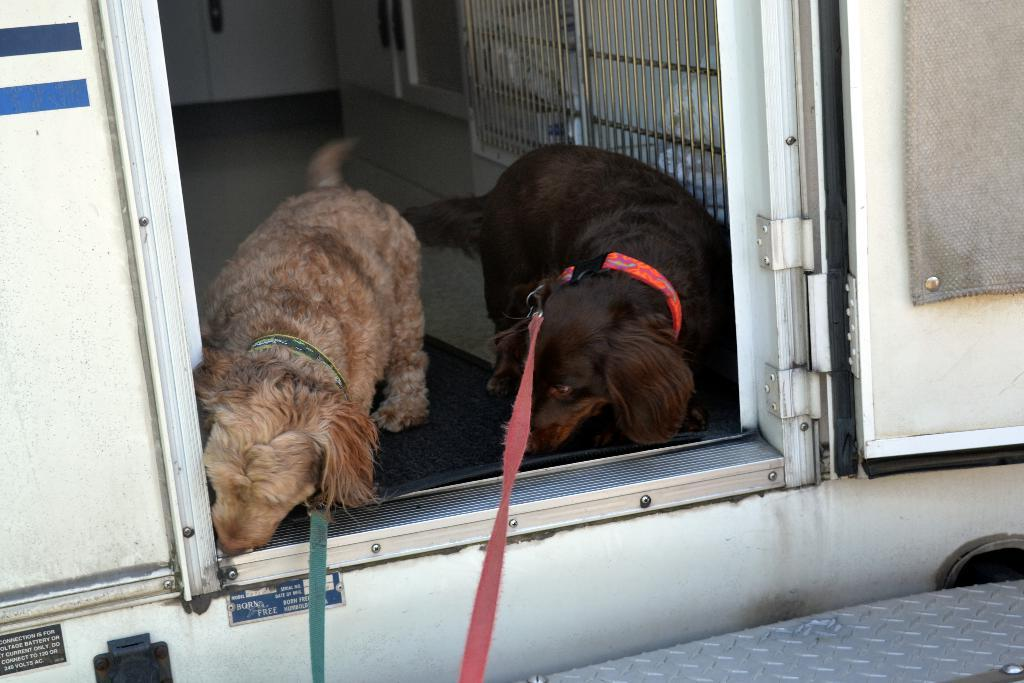How many dogs are in the image? There are two dogs in the image. What are the dogs doing in the image? The dogs are standing at a door. What else can be seen in the background of the image? There is a door and a grill visible in the background of the image. What is the surface that the dogs are standing on? There is a floor visible in the image. What type of soda is being poured into the drain in the image? There is no soda or drain present in the image; it features two dogs standing at a door with a door and grill visible in the background. 